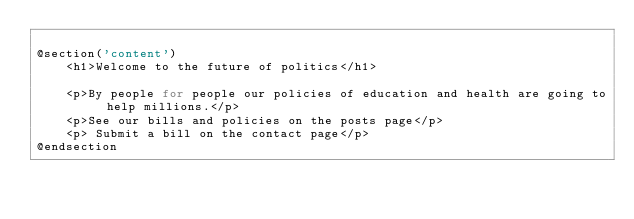Convert code to text. <code><loc_0><loc_0><loc_500><loc_500><_PHP_>
@section('content')
    <h1>Welcome to the future of politics</h1>

    <p>By people for people our policies of education and health are going to help millions.</p>
    <p>See our bills and policies on the posts page</p>
    <p> Submit a bill on the contact page</p>
@endsection
</code> 